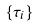Convert formula to latex. <formula><loc_0><loc_0><loc_500><loc_500>\{ \tau _ { i } \}</formula> 